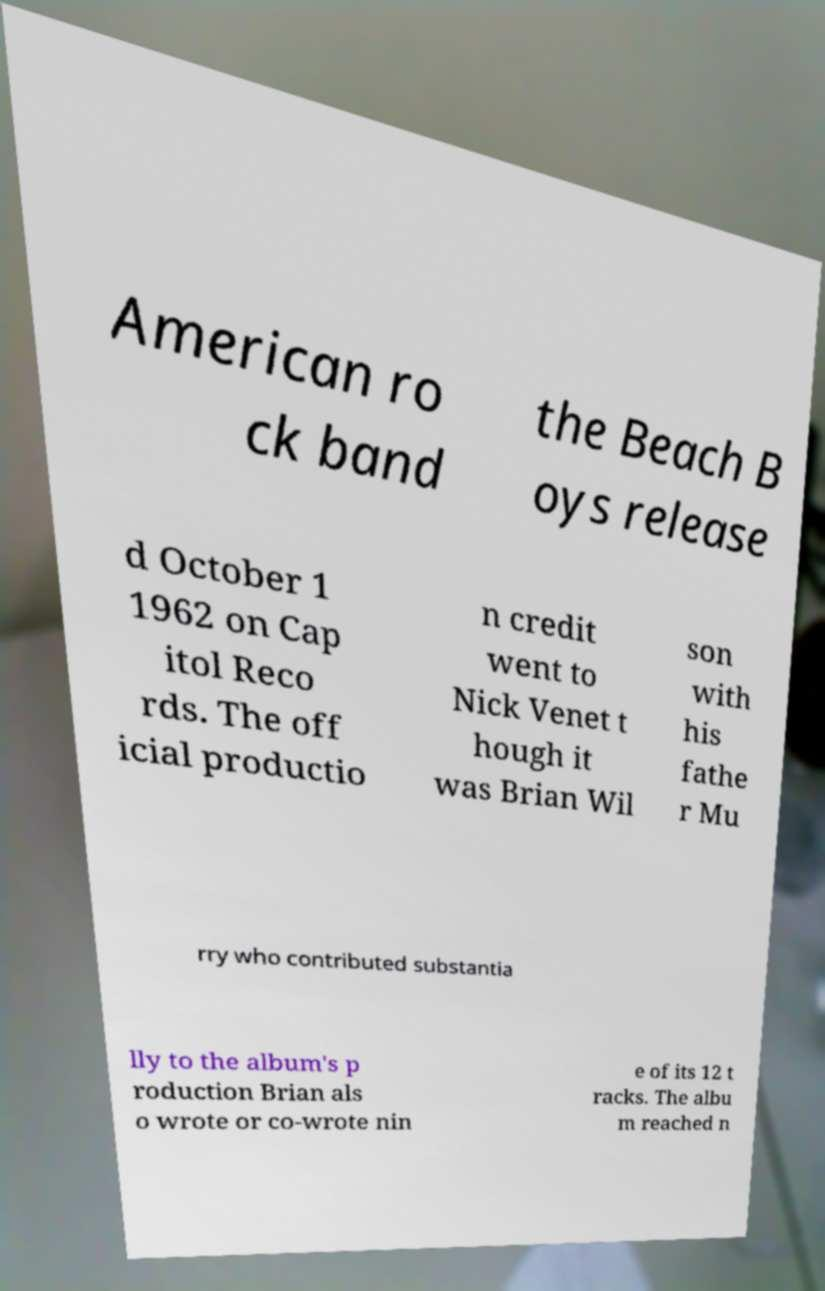Please read and relay the text visible in this image. What does it say? American ro ck band the Beach B oys release d October 1 1962 on Cap itol Reco rds. The off icial productio n credit went to Nick Venet t hough it was Brian Wil son with his fathe r Mu rry who contributed substantia lly to the album's p roduction Brian als o wrote or co-wrote nin e of its 12 t racks. The albu m reached n 